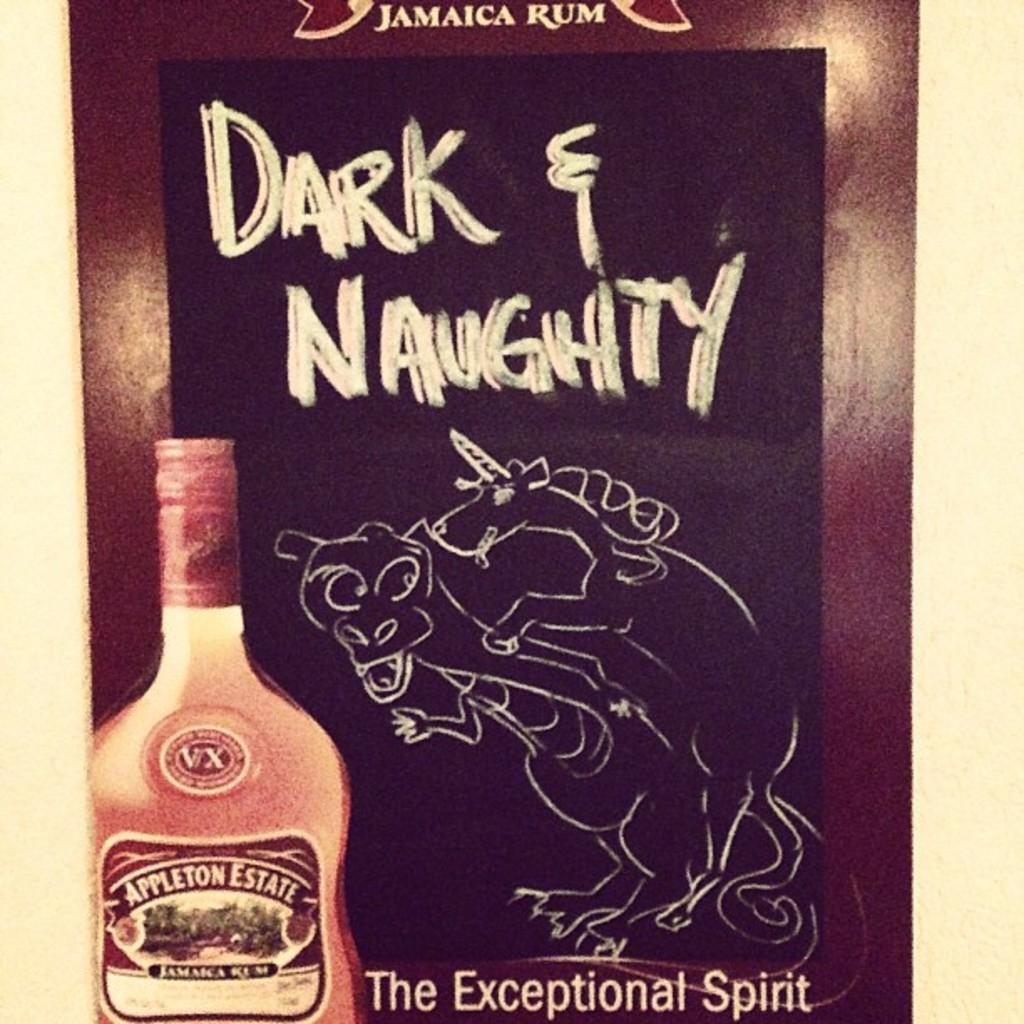What is the brand of liquor?
Your answer should be compact. Appleton estate. 